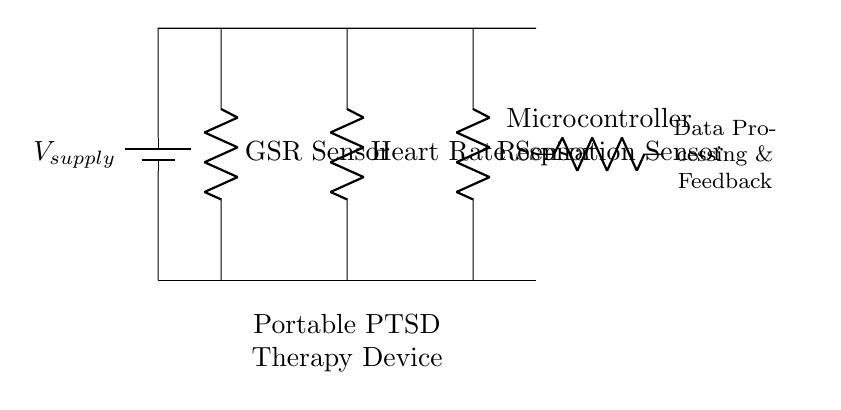What type of circuit is represented in the diagram? The circuit is a parallel circuit, indicated by the multiple branches with components connected to a common voltage supply.
Answer: Parallel What components are included in the therapy device circuit? The circuit includes a GSR sensor, heart rate sensor, respiration sensor, and a microcontroller, as labeled in the diagram.
Answer: GSR sensor, heart rate sensor, respiration sensor, microcontroller How many sensors are connected in the circuit? There are three sensors connected in this parallel circuit, each serving a different function related to biofeedback.
Answer: Three What does the microcontroller do in this circuit? The microcontroller processes data received from the sensors and provides feedback, as indicated by the description next to it.
Answer: Data Processing & Feedback What is the role of the GSR sensor? The GSR sensor measures skin conductance, which can be linked to emotional and physiological states, contributing to PTSD therapy feedback.
Answer: Measures skin conductance How does the parallel configuration affect the current through each sensor? In a parallel circuit, each sensor has its own branch, meaning the current can vary independently through each sensor while maintaining the same voltage level across them.
Answer: Vary independently What is the significance of using a battery in this circuit? The battery supplies the necessary voltage for the circuit to operate, allowing the sensors and microcontroller to function without needing external power.
Answer: Supplies voltage 